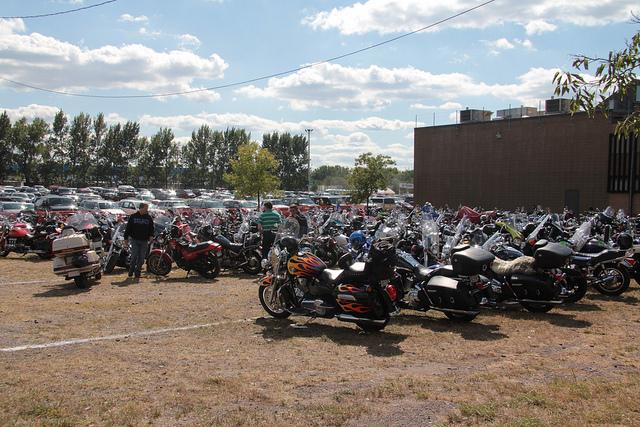What is in the sky?
Be succinct. Clouds. Does the cloud in the upper right corner look like a pirate ship?
Answer briefly. No. Is this considered a cavalry?
Quick response, please. No. Are the bikes parked in the middle of a forest?
Write a very short answer. No. How many motorcycles are there?
Answer briefly. 50. Are the motorcycles on a highway?
Concise answer only. No. 